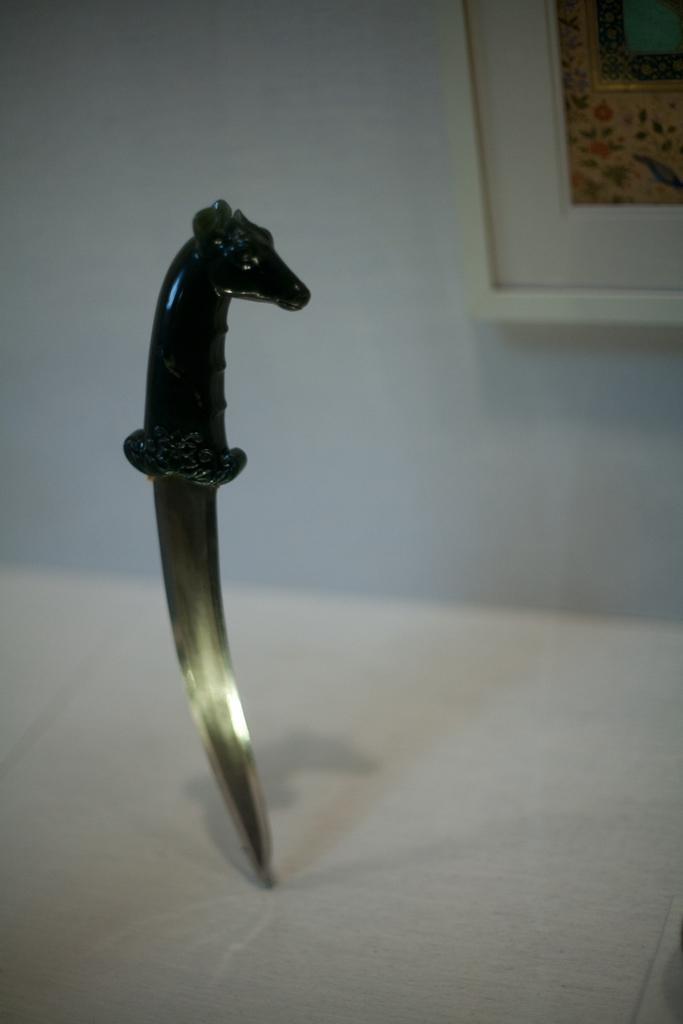In one or two sentences, can you explain what this image depicts? In the foreground of this image, there is a knife on the surface and in the background, there is a frame on the wall. 